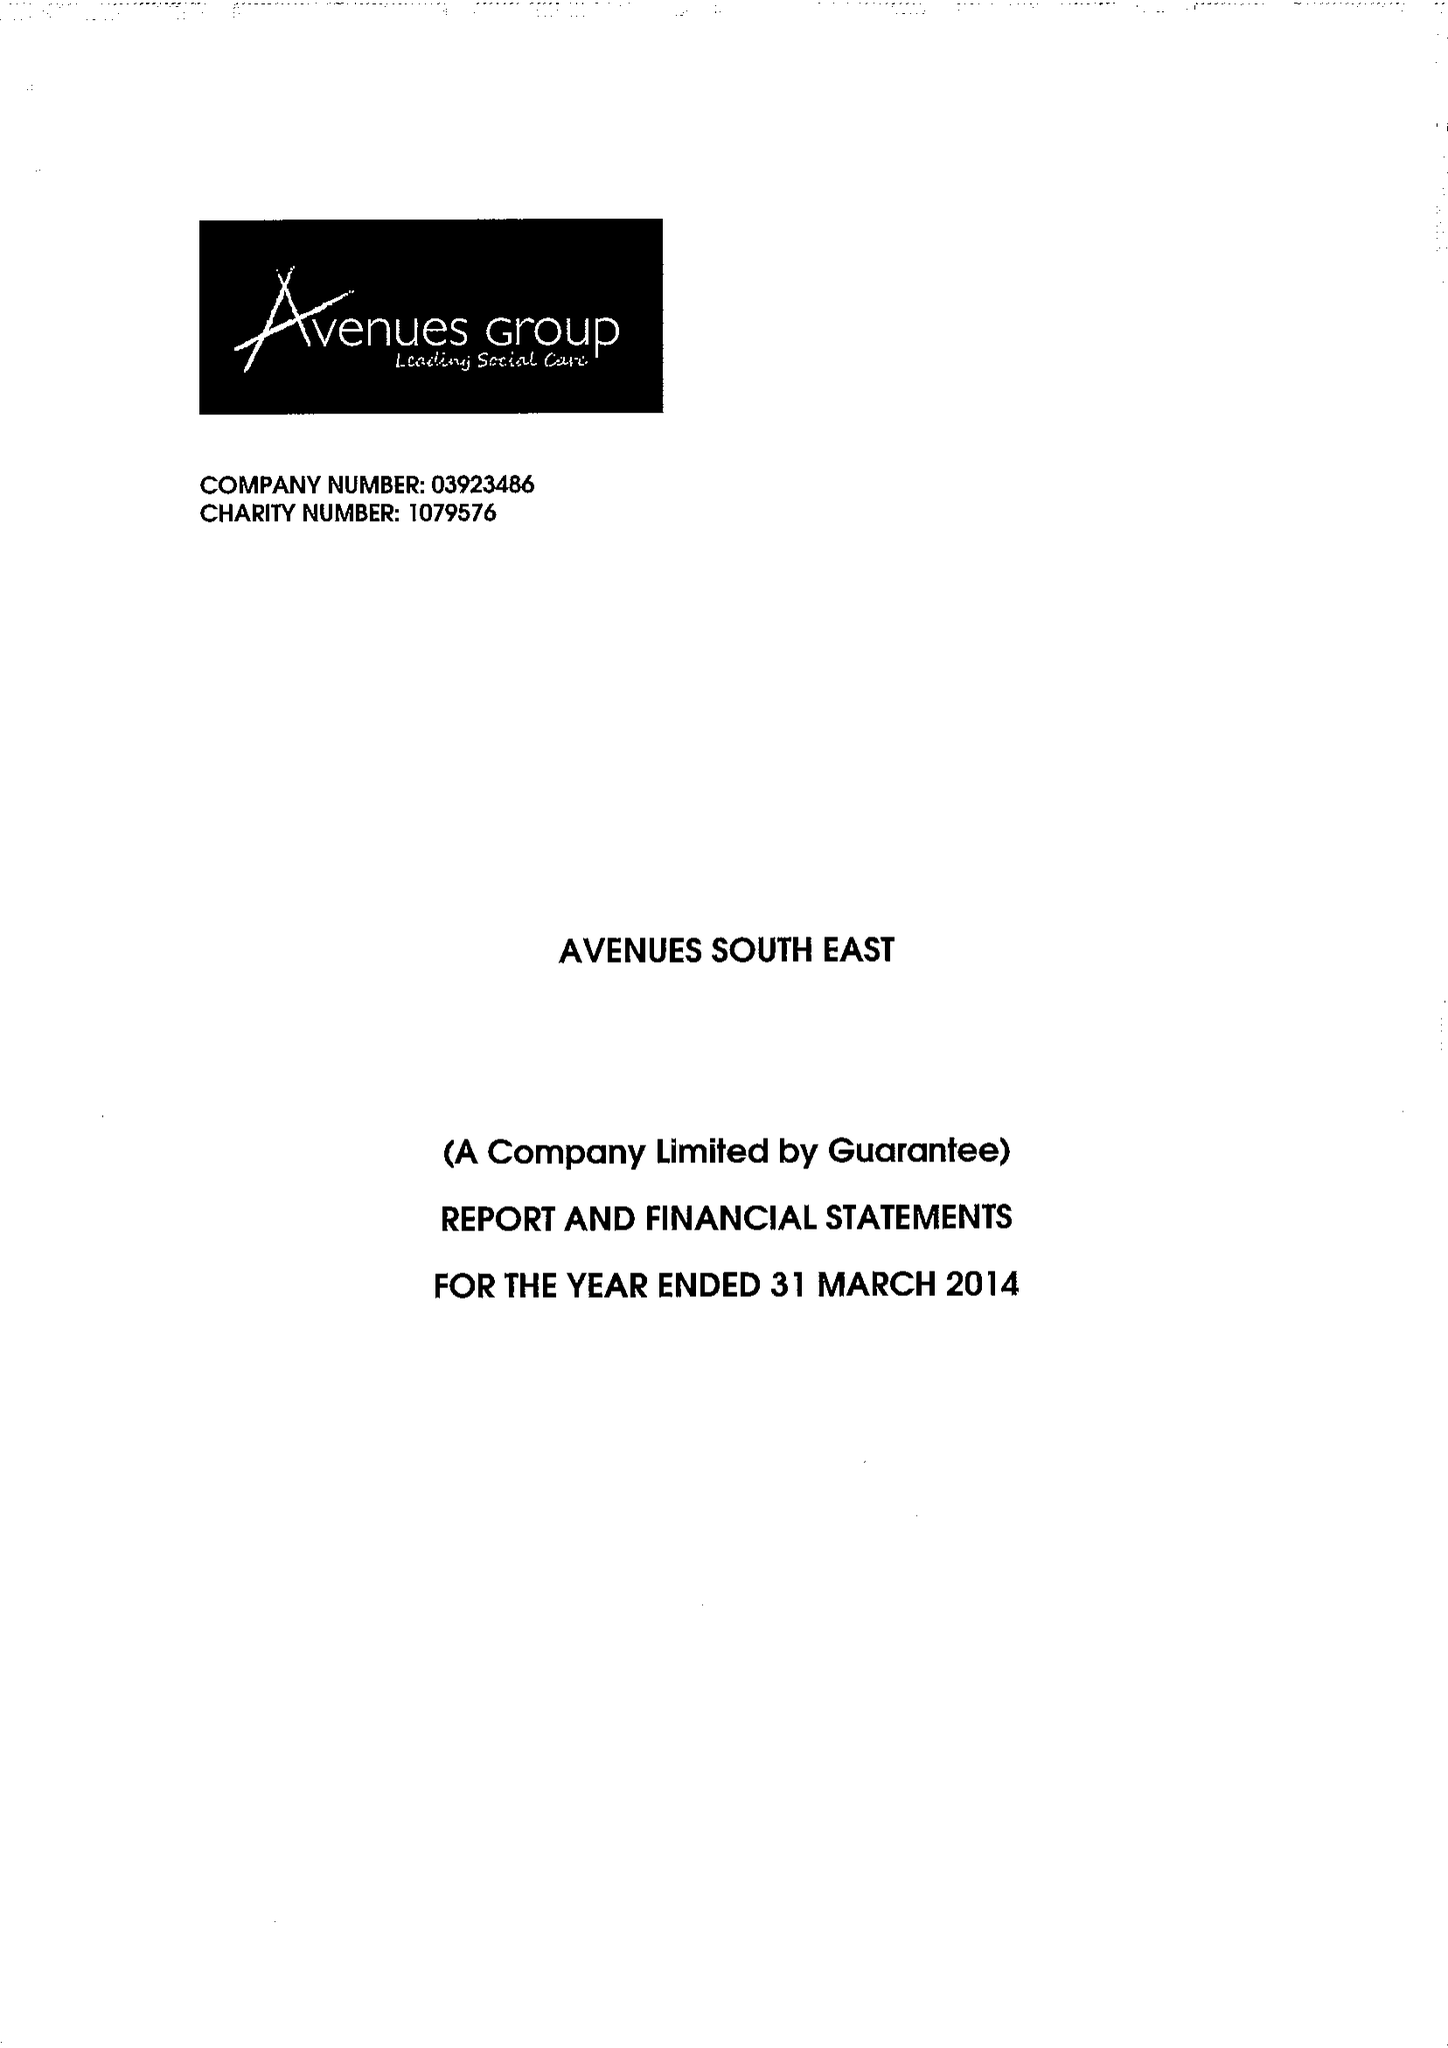What is the value for the charity_name?
Answer the question using a single word or phrase. Avenues South East 